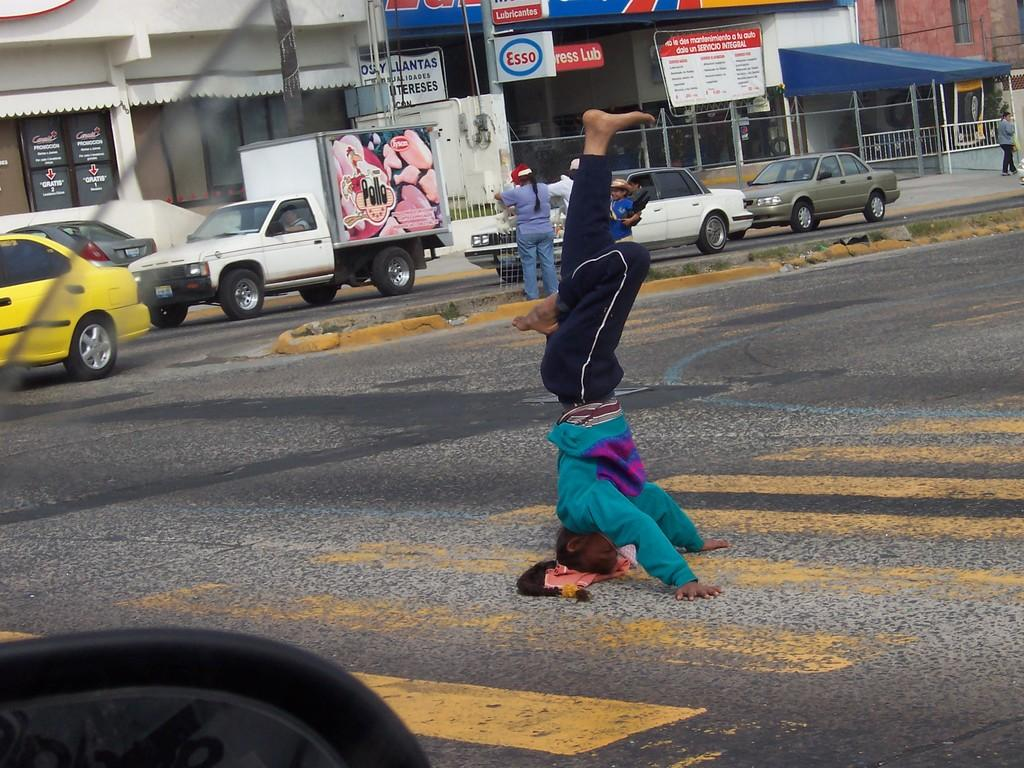<image>
Provide a brief description of the given image. A truck that says Pollo on the side has pictures of chicken meat on it. 